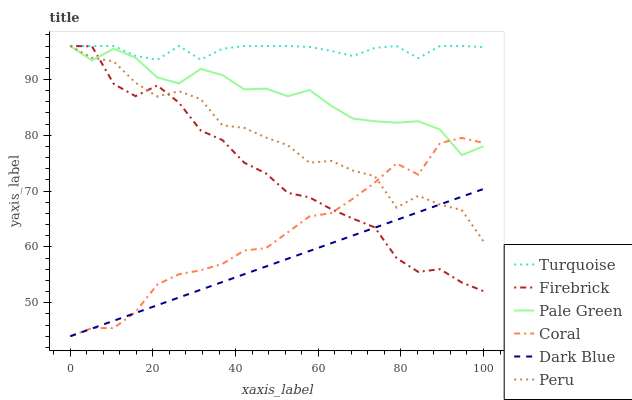Does Dark Blue have the minimum area under the curve?
Answer yes or no. Yes. Does Turquoise have the maximum area under the curve?
Answer yes or no. Yes. Does Coral have the minimum area under the curve?
Answer yes or no. No. Does Coral have the maximum area under the curve?
Answer yes or no. No. Is Dark Blue the smoothest?
Answer yes or no. Yes. Is Peru the roughest?
Answer yes or no. Yes. Is Coral the smoothest?
Answer yes or no. No. Is Coral the roughest?
Answer yes or no. No. Does Coral have the lowest value?
Answer yes or no. Yes. Does Pale Green have the lowest value?
Answer yes or no. No. Does Firebrick have the highest value?
Answer yes or no. Yes. Does Coral have the highest value?
Answer yes or no. No. Is Dark Blue less than Turquoise?
Answer yes or no. Yes. Is Pale Green greater than Dark Blue?
Answer yes or no. Yes. Does Turquoise intersect Pale Green?
Answer yes or no. Yes. Is Turquoise less than Pale Green?
Answer yes or no. No. Is Turquoise greater than Pale Green?
Answer yes or no. No. Does Dark Blue intersect Turquoise?
Answer yes or no. No. 